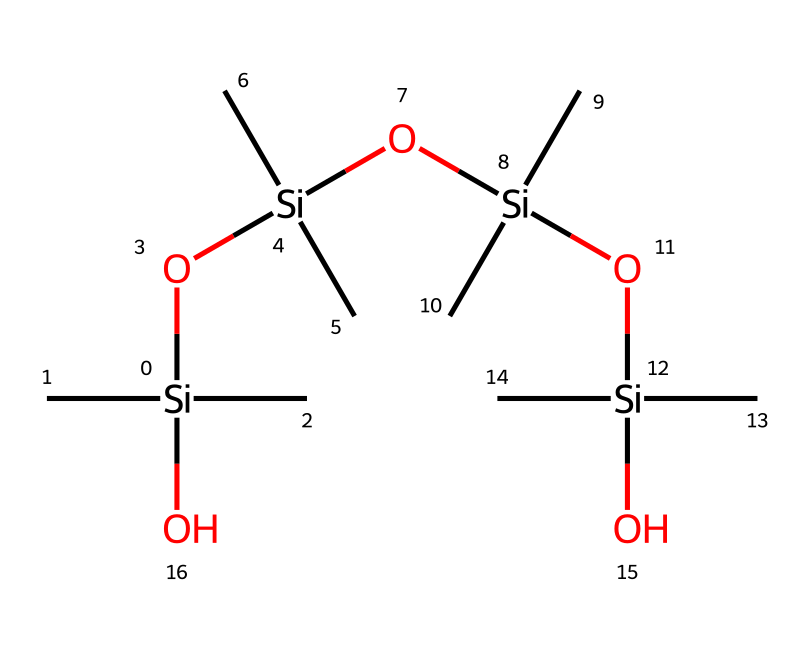What is the main element in the structure? The chemical structure contains silicon atoms as the central element, indicated by the silicon notation [Si].
Answer: silicon How many silicon atoms are present? By examining the SMILES representation, we identify four distinct silicon atoms represented by the [Si] notation throughout the chemical structure.
Answer: four What type of bonding is predominantly present in this compound? The chemical structure indicates a siloxane linkage, characterized by Si-O bonds, which are different from carbon-based bonds due to the presence of silicon and oxygen.
Answer: siloxane What functional groups can be identified in this compound? The structure prominently features silanol groups (-Si-OH) due to the presence of oxygen atoms bonded to silicon, indicating that it can engage in hydrogen bonding.
Answer: silanol How does this chemical help in anti-static applications? The polysiloxane's ability to minimize static charge buildup is attributed to its low surface energy and coating properties derived from the long siloxane chains.
Answer: minimizes static charge What is the repeating unit in polysiloxanes? The repeating unit in polysiloxanes consists of a siloxane bond that incorporates alternating silicon and oxygen atoms, creating a linear or branched polymer.
Answer: siloxane bond What is the overall charge of this compound at neutral pH? The compound is neutral as it does not contain any charged functional groups or ions in its structure, making it non-ionic.
Answer: neutral 